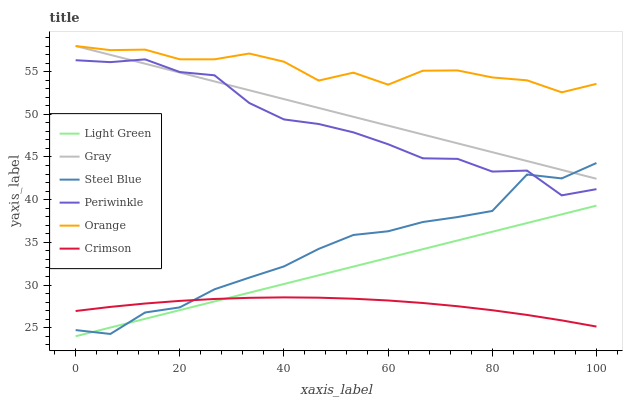Does Crimson have the minimum area under the curve?
Answer yes or no. Yes. Does Orange have the maximum area under the curve?
Answer yes or no. Yes. Does Steel Blue have the minimum area under the curve?
Answer yes or no. No. Does Steel Blue have the maximum area under the curve?
Answer yes or no. No. Is Gray the smoothest?
Answer yes or no. Yes. Is Steel Blue the roughest?
Answer yes or no. Yes. Is Crimson the smoothest?
Answer yes or no. No. Is Crimson the roughest?
Answer yes or no. No. Does Light Green have the lowest value?
Answer yes or no. Yes. Does Steel Blue have the lowest value?
Answer yes or no. No. Does Orange have the highest value?
Answer yes or no. Yes. Does Steel Blue have the highest value?
Answer yes or no. No. Is Periwinkle less than Orange?
Answer yes or no. Yes. Is Orange greater than Crimson?
Answer yes or no. Yes. Does Crimson intersect Light Green?
Answer yes or no. Yes. Is Crimson less than Light Green?
Answer yes or no. No. Is Crimson greater than Light Green?
Answer yes or no. No. Does Periwinkle intersect Orange?
Answer yes or no. No. 